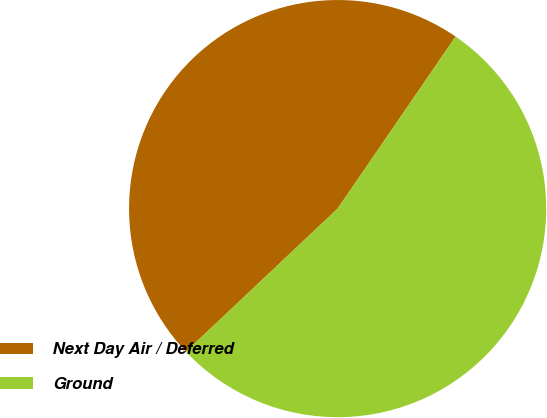Convert chart. <chart><loc_0><loc_0><loc_500><loc_500><pie_chart><fcel>Next Day Air / Deferred<fcel>Ground<nl><fcel>46.6%<fcel>53.4%<nl></chart> 